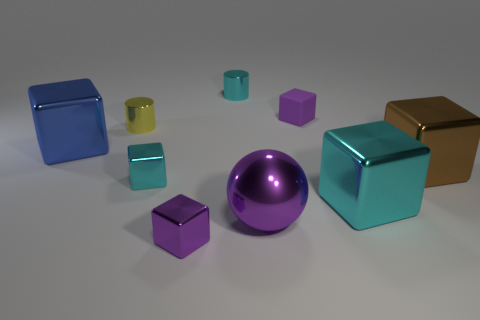Is there any other thing that is the same shape as the large purple object?
Give a very brief answer. No. There is a tiny matte object; does it have the same color as the big thing in front of the big cyan thing?
Provide a succinct answer. Yes. There is a tiny purple thing in front of the blue thing; what shape is it?
Keep it short and to the point. Cube. How many other objects are the same material as the small cyan cube?
Provide a succinct answer. 7. What is the big brown object made of?
Offer a terse response. Metal. What number of large things are brown cylinders or purple metal cubes?
Keep it short and to the point. 0. There is a yellow thing; what number of big shiny things are right of it?
Your answer should be compact. 3. Is there a rubber cube that has the same color as the large shiny ball?
Provide a short and direct response. Yes. There is a cyan object that is the same size as the sphere; what shape is it?
Offer a terse response. Cube. What number of red things are cylinders or big spheres?
Provide a succinct answer. 0. 